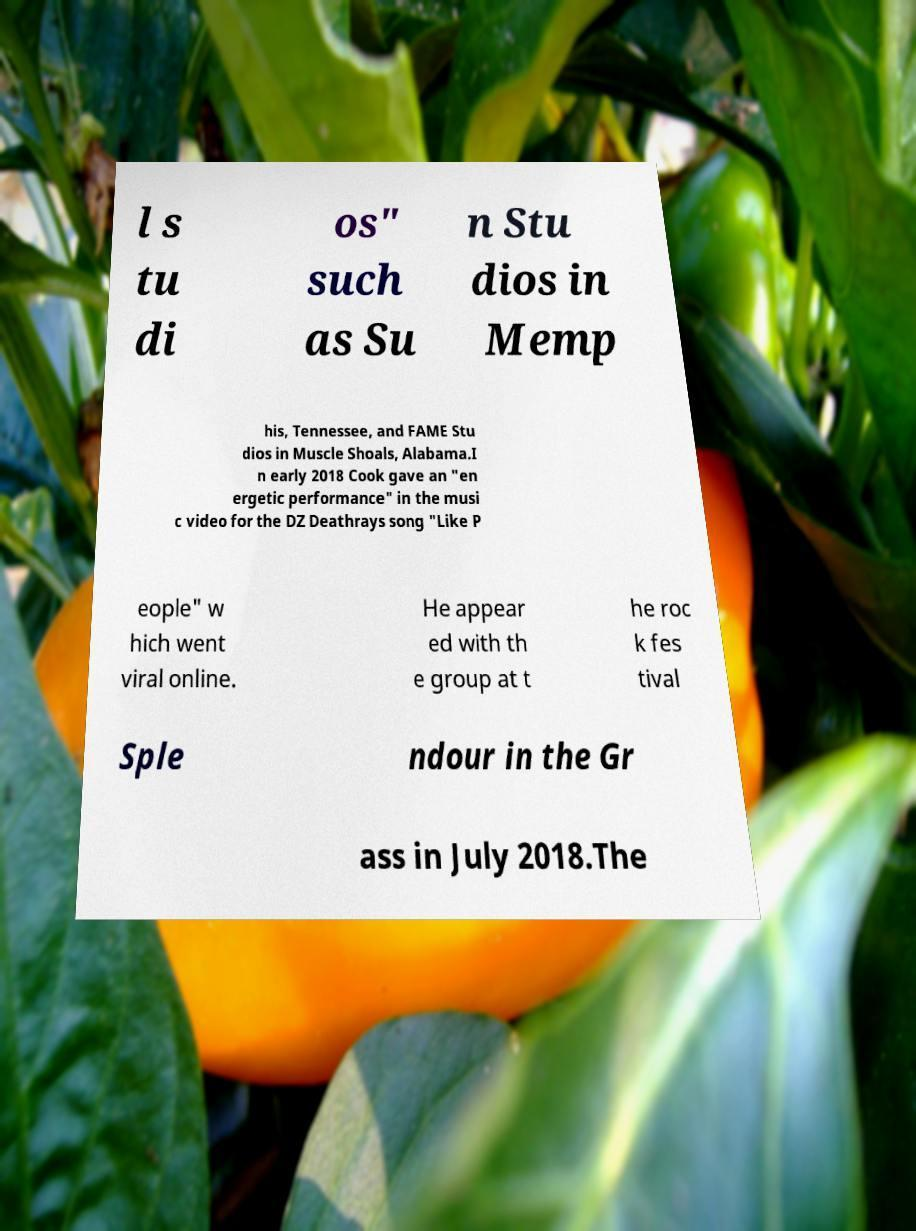Please read and relay the text visible in this image. What does it say? l s tu di os" such as Su n Stu dios in Memp his, Tennessee, and FAME Stu dios in Muscle Shoals, Alabama.I n early 2018 Cook gave an "en ergetic performance" in the musi c video for the DZ Deathrays song "Like P eople" w hich went viral online. He appear ed with th e group at t he roc k fes tival Sple ndour in the Gr ass in July 2018.The 